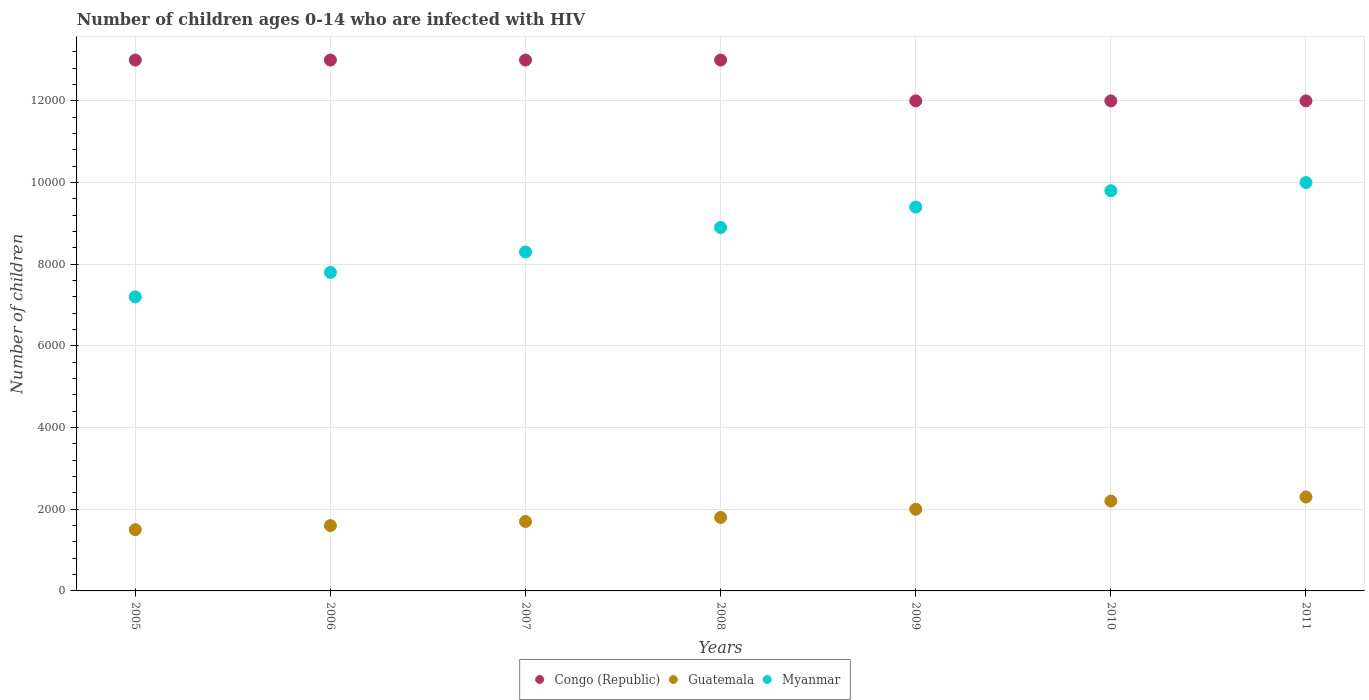How many different coloured dotlines are there?
Make the answer very short. 3. Is the number of dotlines equal to the number of legend labels?
Make the answer very short. Yes. What is the number of HIV infected children in Congo (Republic) in 2005?
Ensure brevity in your answer.  1.30e+04. Across all years, what is the maximum number of HIV infected children in Congo (Republic)?
Keep it short and to the point. 1.30e+04. Across all years, what is the minimum number of HIV infected children in Congo (Republic)?
Your answer should be compact. 1.20e+04. In which year was the number of HIV infected children in Congo (Republic) maximum?
Your response must be concise. 2005. In which year was the number of HIV infected children in Congo (Republic) minimum?
Keep it short and to the point. 2009. What is the total number of HIV infected children in Guatemala in the graph?
Provide a short and direct response. 1.31e+04. What is the difference between the number of HIV infected children in Guatemala in 2008 and that in 2011?
Offer a very short reply. -500. What is the difference between the number of HIV infected children in Guatemala in 2006 and the number of HIV infected children in Myanmar in 2005?
Make the answer very short. -5600. What is the average number of HIV infected children in Guatemala per year?
Make the answer very short. 1871.43. In the year 2010, what is the difference between the number of HIV infected children in Congo (Republic) and number of HIV infected children in Myanmar?
Offer a terse response. 2200. What is the ratio of the number of HIV infected children in Guatemala in 2007 to that in 2010?
Make the answer very short. 0.77. Is the number of HIV infected children in Myanmar in 2005 less than that in 2007?
Provide a succinct answer. Yes. Is the difference between the number of HIV infected children in Congo (Republic) in 2005 and 2006 greater than the difference between the number of HIV infected children in Myanmar in 2005 and 2006?
Provide a short and direct response. Yes. What is the difference between the highest and the lowest number of HIV infected children in Congo (Republic)?
Ensure brevity in your answer.  1000. In how many years, is the number of HIV infected children in Congo (Republic) greater than the average number of HIV infected children in Congo (Republic) taken over all years?
Your answer should be very brief. 4. Is the sum of the number of HIV infected children in Guatemala in 2005 and 2007 greater than the maximum number of HIV infected children in Congo (Republic) across all years?
Offer a very short reply. No. Is it the case that in every year, the sum of the number of HIV infected children in Myanmar and number of HIV infected children in Guatemala  is greater than the number of HIV infected children in Congo (Republic)?
Offer a terse response. No. Does the number of HIV infected children in Congo (Republic) monotonically increase over the years?
Make the answer very short. No. How many years are there in the graph?
Give a very brief answer. 7. Are the values on the major ticks of Y-axis written in scientific E-notation?
Your response must be concise. No. Does the graph contain grids?
Keep it short and to the point. Yes. How many legend labels are there?
Your answer should be very brief. 3. How are the legend labels stacked?
Keep it short and to the point. Horizontal. What is the title of the graph?
Keep it short and to the point. Number of children ages 0-14 who are infected with HIV. What is the label or title of the X-axis?
Provide a short and direct response. Years. What is the label or title of the Y-axis?
Your response must be concise. Number of children. What is the Number of children of Congo (Republic) in 2005?
Provide a short and direct response. 1.30e+04. What is the Number of children of Guatemala in 2005?
Provide a short and direct response. 1500. What is the Number of children of Myanmar in 2005?
Give a very brief answer. 7200. What is the Number of children in Congo (Republic) in 2006?
Your answer should be compact. 1.30e+04. What is the Number of children of Guatemala in 2006?
Your response must be concise. 1600. What is the Number of children in Myanmar in 2006?
Provide a short and direct response. 7800. What is the Number of children of Congo (Republic) in 2007?
Provide a short and direct response. 1.30e+04. What is the Number of children of Guatemala in 2007?
Give a very brief answer. 1700. What is the Number of children in Myanmar in 2007?
Keep it short and to the point. 8300. What is the Number of children in Congo (Republic) in 2008?
Your answer should be very brief. 1.30e+04. What is the Number of children of Guatemala in 2008?
Your answer should be compact. 1800. What is the Number of children of Myanmar in 2008?
Offer a terse response. 8900. What is the Number of children in Congo (Republic) in 2009?
Offer a terse response. 1.20e+04. What is the Number of children of Myanmar in 2009?
Offer a very short reply. 9400. What is the Number of children of Congo (Republic) in 2010?
Keep it short and to the point. 1.20e+04. What is the Number of children in Guatemala in 2010?
Give a very brief answer. 2200. What is the Number of children of Myanmar in 2010?
Offer a very short reply. 9800. What is the Number of children in Congo (Republic) in 2011?
Keep it short and to the point. 1.20e+04. What is the Number of children in Guatemala in 2011?
Keep it short and to the point. 2300. Across all years, what is the maximum Number of children in Congo (Republic)?
Make the answer very short. 1.30e+04. Across all years, what is the maximum Number of children in Guatemala?
Provide a succinct answer. 2300. Across all years, what is the maximum Number of children of Myanmar?
Offer a terse response. 10000. Across all years, what is the minimum Number of children in Congo (Republic)?
Offer a very short reply. 1.20e+04. Across all years, what is the minimum Number of children of Guatemala?
Make the answer very short. 1500. Across all years, what is the minimum Number of children of Myanmar?
Offer a terse response. 7200. What is the total Number of children in Congo (Republic) in the graph?
Offer a terse response. 8.80e+04. What is the total Number of children in Guatemala in the graph?
Your answer should be compact. 1.31e+04. What is the total Number of children of Myanmar in the graph?
Your response must be concise. 6.14e+04. What is the difference between the Number of children in Congo (Republic) in 2005 and that in 2006?
Your answer should be very brief. 0. What is the difference between the Number of children of Guatemala in 2005 and that in 2006?
Offer a very short reply. -100. What is the difference between the Number of children of Myanmar in 2005 and that in 2006?
Keep it short and to the point. -600. What is the difference between the Number of children of Congo (Republic) in 2005 and that in 2007?
Your answer should be very brief. 0. What is the difference between the Number of children of Guatemala in 2005 and that in 2007?
Make the answer very short. -200. What is the difference between the Number of children of Myanmar in 2005 and that in 2007?
Offer a very short reply. -1100. What is the difference between the Number of children of Guatemala in 2005 and that in 2008?
Your answer should be very brief. -300. What is the difference between the Number of children of Myanmar in 2005 and that in 2008?
Offer a very short reply. -1700. What is the difference between the Number of children in Congo (Republic) in 2005 and that in 2009?
Ensure brevity in your answer.  1000. What is the difference between the Number of children in Guatemala in 2005 and that in 2009?
Make the answer very short. -500. What is the difference between the Number of children in Myanmar in 2005 and that in 2009?
Make the answer very short. -2200. What is the difference between the Number of children of Guatemala in 2005 and that in 2010?
Give a very brief answer. -700. What is the difference between the Number of children in Myanmar in 2005 and that in 2010?
Keep it short and to the point. -2600. What is the difference between the Number of children of Congo (Republic) in 2005 and that in 2011?
Provide a succinct answer. 1000. What is the difference between the Number of children in Guatemala in 2005 and that in 2011?
Make the answer very short. -800. What is the difference between the Number of children of Myanmar in 2005 and that in 2011?
Provide a succinct answer. -2800. What is the difference between the Number of children of Congo (Republic) in 2006 and that in 2007?
Offer a very short reply. 0. What is the difference between the Number of children in Guatemala in 2006 and that in 2007?
Provide a short and direct response. -100. What is the difference between the Number of children of Myanmar in 2006 and that in 2007?
Offer a terse response. -500. What is the difference between the Number of children in Congo (Republic) in 2006 and that in 2008?
Offer a very short reply. 0. What is the difference between the Number of children in Guatemala in 2006 and that in 2008?
Give a very brief answer. -200. What is the difference between the Number of children in Myanmar in 2006 and that in 2008?
Make the answer very short. -1100. What is the difference between the Number of children in Congo (Republic) in 2006 and that in 2009?
Provide a succinct answer. 1000. What is the difference between the Number of children of Guatemala in 2006 and that in 2009?
Give a very brief answer. -400. What is the difference between the Number of children in Myanmar in 2006 and that in 2009?
Your response must be concise. -1600. What is the difference between the Number of children of Guatemala in 2006 and that in 2010?
Make the answer very short. -600. What is the difference between the Number of children in Myanmar in 2006 and that in 2010?
Your response must be concise. -2000. What is the difference between the Number of children of Congo (Republic) in 2006 and that in 2011?
Your answer should be very brief. 1000. What is the difference between the Number of children of Guatemala in 2006 and that in 2011?
Your response must be concise. -700. What is the difference between the Number of children in Myanmar in 2006 and that in 2011?
Provide a short and direct response. -2200. What is the difference between the Number of children in Guatemala in 2007 and that in 2008?
Give a very brief answer. -100. What is the difference between the Number of children of Myanmar in 2007 and that in 2008?
Offer a very short reply. -600. What is the difference between the Number of children in Congo (Republic) in 2007 and that in 2009?
Give a very brief answer. 1000. What is the difference between the Number of children in Guatemala in 2007 and that in 2009?
Your answer should be very brief. -300. What is the difference between the Number of children of Myanmar in 2007 and that in 2009?
Make the answer very short. -1100. What is the difference between the Number of children of Guatemala in 2007 and that in 2010?
Make the answer very short. -500. What is the difference between the Number of children of Myanmar in 2007 and that in 2010?
Provide a short and direct response. -1500. What is the difference between the Number of children in Guatemala in 2007 and that in 2011?
Keep it short and to the point. -600. What is the difference between the Number of children of Myanmar in 2007 and that in 2011?
Give a very brief answer. -1700. What is the difference between the Number of children of Congo (Republic) in 2008 and that in 2009?
Your answer should be compact. 1000. What is the difference between the Number of children in Guatemala in 2008 and that in 2009?
Provide a succinct answer. -200. What is the difference between the Number of children of Myanmar in 2008 and that in 2009?
Provide a short and direct response. -500. What is the difference between the Number of children in Congo (Republic) in 2008 and that in 2010?
Make the answer very short. 1000. What is the difference between the Number of children in Guatemala in 2008 and that in 2010?
Your response must be concise. -400. What is the difference between the Number of children of Myanmar in 2008 and that in 2010?
Provide a succinct answer. -900. What is the difference between the Number of children of Guatemala in 2008 and that in 2011?
Offer a very short reply. -500. What is the difference between the Number of children in Myanmar in 2008 and that in 2011?
Your answer should be compact. -1100. What is the difference between the Number of children in Congo (Republic) in 2009 and that in 2010?
Your answer should be compact. 0. What is the difference between the Number of children in Guatemala in 2009 and that in 2010?
Keep it short and to the point. -200. What is the difference between the Number of children of Myanmar in 2009 and that in 2010?
Ensure brevity in your answer.  -400. What is the difference between the Number of children in Guatemala in 2009 and that in 2011?
Keep it short and to the point. -300. What is the difference between the Number of children in Myanmar in 2009 and that in 2011?
Provide a succinct answer. -600. What is the difference between the Number of children of Congo (Republic) in 2010 and that in 2011?
Keep it short and to the point. 0. What is the difference between the Number of children of Guatemala in 2010 and that in 2011?
Keep it short and to the point. -100. What is the difference between the Number of children in Myanmar in 2010 and that in 2011?
Offer a terse response. -200. What is the difference between the Number of children of Congo (Republic) in 2005 and the Number of children of Guatemala in 2006?
Make the answer very short. 1.14e+04. What is the difference between the Number of children in Congo (Republic) in 2005 and the Number of children in Myanmar in 2006?
Give a very brief answer. 5200. What is the difference between the Number of children of Guatemala in 2005 and the Number of children of Myanmar in 2006?
Provide a succinct answer. -6300. What is the difference between the Number of children in Congo (Republic) in 2005 and the Number of children in Guatemala in 2007?
Provide a succinct answer. 1.13e+04. What is the difference between the Number of children in Congo (Republic) in 2005 and the Number of children in Myanmar in 2007?
Keep it short and to the point. 4700. What is the difference between the Number of children of Guatemala in 2005 and the Number of children of Myanmar in 2007?
Your answer should be very brief. -6800. What is the difference between the Number of children of Congo (Republic) in 2005 and the Number of children of Guatemala in 2008?
Provide a succinct answer. 1.12e+04. What is the difference between the Number of children of Congo (Republic) in 2005 and the Number of children of Myanmar in 2008?
Give a very brief answer. 4100. What is the difference between the Number of children in Guatemala in 2005 and the Number of children in Myanmar in 2008?
Provide a succinct answer. -7400. What is the difference between the Number of children of Congo (Republic) in 2005 and the Number of children of Guatemala in 2009?
Offer a terse response. 1.10e+04. What is the difference between the Number of children of Congo (Republic) in 2005 and the Number of children of Myanmar in 2009?
Offer a terse response. 3600. What is the difference between the Number of children in Guatemala in 2005 and the Number of children in Myanmar in 2009?
Provide a short and direct response. -7900. What is the difference between the Number of children of Congo (Republic) in 2005 and the Number of children of Guatemala in 2010?
Your answer should be compact. 1.08e+04. What is the difference between the Number of children in Congo (Republic) in 2005 and the Number of children in Myanmar in 2010?
Offer a very short reply. 3200. What is the difference between the Number of children in Guatemala in 2005 and the Number of children in Myanmar in 2010?
Offer a terse response. -8300. What is the difference between the Number of children of Congo (Republic) in 2005 and the Number of children of Guatemala in 2011?
Your response must be concise. 1.07e+04. What is the difference between the Number of children of Congo (Republic) in 2005 and the Number of children of Myanmar in 2011?
Your response must be concise. 3000. What is the difference between the Number of children of Guatemala in 2005 and the Number of children of Myanmar in 2011?
Offer a terse response. -8500. What is the difference between the Number of children in Congo (Republic) in 2006 and the Number of children in Guatemala in 2007?
Ensure brevity in your answer.  1.13e+04. What is the difference between the Number of children of Congo (Republic) in 2006 and the Number of children of Myanmar in 2007?
Offer a very short reply. 4700. What is the difference between the Number of children of Guatemala in 2006 and the Number of children of Myanmar in 2007?
Provide a short and direct response. -6700. What is the difference between the Number of children of Congo (Republic) in 2006 and the Number of children of Guatemala in 2008?
Offer a terse response. 1.12e+04. What is the difference between the Number of children of Congo (Republic) in 2006 and the Number of children of Myanmar in 2008?
Offer a terse response. 4100. What is the difference between the Number of children of Guatemala in 2006 and the Number of children of Myanmar in 2008?
Give a very brief answer. -7300. What is the difference between the Number of children of Congo (Republic) in 2006 and the Number of children of Guatemala in 2009?
Offer a very short reply. 1.10e+04. What is the difference between the Number of children in Congo (Republic) in 2006 and the Number of children in Myanmar in 2009?
Your response must be concise. 3600. What is the difference between the Number of children in Guatemala in 2006 and the Number of children in Myanmar in 2009?
Provide a short and direct response. -7800. What is the difference between the Number of children in Congo (Republic) in 2006 and the Number of children in Guatemala in 2010?
Provide a short and direct response. 1.08e+04. What is the difference between the Number of children of Congo (Republic) in 2006 and the Number of children of Myanmar in 2010?
Give a very brief answer. 3200. What is the difference between the Number of children of Guatemala in 2006 and the Number of children of Myanmar in 2010?
Give a very brief answer. -8200. What is the difference between the Number of children of Congo (Republic) in 2006 and the Number of children of Guatemala in 2011?
Offer a terse response. 1.07e+04. What is the difference between the Number of children of Congo (Republic) in 2006 and the Number of children of Myanmar in 2011?
Ensure brevity in your answer.  3000. What is the difference between the Number of children in Guatemala in 2006 and the Number of children in Myanmar in 2011?
Ensure brevity in your answer.  -8400. What is the difference between the Number of children in Congo (Republic) in 2007 and the Number of children in Guatemala in 2008?
Keep it short and to the point. 1.12e+04. What is the difference between the Number of children of Congo (Republic) in 2007 and the Number of children of Myanmar in 2008?
Offer a terse response. 4100. What is the difference between the Number of children in Guatemala in 2007 and the Number of children in Myanmar in 2008?
Ensure brevity in your answer.  -7200. What is the difference between the Number of children of Congo (Republic) in 2007 and the Number of children of Guatemala in 2009?
Your answer should be very brief. 1.10e+04. What is the difference between the Number of children in Congo (Republic) in 2007 and the Number of children in Myanmar in 2009?
Give a very brief answer. 3600. What is the difference between the Number of children of Guatemala in 2007 and the Number of children of Myanmar in 2009?
Give a very brief answer. -7700. What is the difference between the Number of children in Congo (Republic) in 2007 and the Number of children in Guatemala in 2010?
Offer a very short reply. 1.08e+04. What is the difference between the Number of children in Congo (Republic) in 2007 and the Number of children in Myanmar in 2010?
Ensure brevity in your answer.  3200. What is the difference between the Number of children in Guatemala in 2007 and the Number of children in Myanmar in 2010?
Your response must be concise. -8100. What is the difference between the Number of children in Congo (Republic) in 2007 and the Number of children in Guatemala in 2011?
Offer a very short reply. 1.07e+04. What is the difference between the Number of children of Congo (Republic) in 2007 and the Number of children of Myanmar in 2011?
Keep it short and to the point. 3000. What is the difference between the Number of children of Guatemala in 2007 and the Number of children of Myanmar in 2011?
Offer a very short reply. -8300. What is the difference between the Number of children of Congo (Republic) in 2008 and the Number of children of Guatemala in 2009?
Provide a short and direct response. 1.10e+04. What is the difference between the Number of children of Congo (Republic) in 2008 and the Number of children of Myanmar in 2009?
Provide a succinct answer. 3600. What is the difference between the Number of children in Guatemala in 2008 and the Number of children in Myanmar in 2009?
Ensure brevity in your answer.  -7600. What is the difference between the Number of children in Congo (Republic) in 2008 and the Number of children in Guatemala in 2010?
Offer a very short reply. 1.08e+04. What is the difference between the Number of children of Congo (Republic) in 2008 and the Number of children of Myanmar in 2010?
Your answer should be compact. 3200. What is the difference between the Number of children of Guatemala in 2008 and the Number of children of Myanmar in 2010?
Give a very brief answer. -8000. What is the difference between the Number of children in Congo (Republic) in 2008 and the Number of children in Guatemala in 2011?
Provide a short and direct response. 1.07e+04. What is the difference between the Number of children of Congo (Republic) in 2008 and the Number of children of Myanmar in 2011?
Offer a terse response. 3000. What is the difference between the Number of children of Guatemala in 2008 and the Number of children of Myanmar in 2011?
Provide a succinct answer. -8200. What is the difference between the Number of children of Congo (Republic) in 2009 and the Number of children of Guatemala in 2010?
Provide a short and direct response. 9800. What is the difference between the Number of children in Congo (Republic) in 2009 and the Number of children in Myanmar in 2010?
Make the answer very short. 2200. What is the difference between the Number of children in Guatemala in 2009 and the Number of children in Myanmar in 2010?
Your answer should be very brief. -7800. What is the difference between the Number of children of Congo (Republic) in 2009 and the Number of children of Guatemala in 2011?
Provide a short and direct response. 9700. What is the difference between the Number of children in Guatemala in 2009 and the Number of children in Myanmar in 2011?
Provide a short and direct response. -8000. What is the difference between the Number of children of Congo (Republic) in 2010 and the Number of children of Guatemala in 2011?
Keep it short and to the point. 9700. What is the difference between the Number of children in Guatemala in 2010 and the Number of children in Myanmar in 2011?
Keep it short and to the point. -7800. What is the average Number of children of Congo (Republic) per year?
Make the answer very short. 1.26e+04. What is the average Number of children in Guatemala per year?
Your answer should be compact. 1871.43. What is the average Number of children in Myanmar per year?
Make the answer very short. 8771.43. In the year 2005, what is the difference between the Number of children of Congo (Republic) and Number of children of Guatemala?
Make the answer very short. 1.15e+04. In the year 2005, what is the difference between the Number of children of Congo (Republic) and Number of children of Myanmar?
Keep it short and to the point. 5800. In the year 2005, what is the difference between the Number of children in Guatemala and Number of children in Myanmar?
Make the answer very short. -5700. In the year 2006, what is the difference between the Number of children in Congo (Republic) and Number of children in Guatemala?
Offer a terse response. 1.14e+04. In the year 2006, what is the difference between the Number of children in Congo (Republic) and Number of children in Myanmar?
Offer a terse response. 5200. In the year 2006, what is the difference between the Number of children of Guatemala and Number of children of Myanmar?
Your response must be concise. -6200. In the year 2007, what is the difference between the Number of children in Congo (Republic) and Number of children in Guatemala?
Your answer should be compact. 1.13e+04. In the year 2007, what is the difference between the Number of children of Congo (Republic) and Number of children of Myanmar?
Your answer should be very brief. 4700. In the year 2007, what is the difference between the Number of children in Guatemala and Number of children in Myanmar?
Your response must be concise. -6600. In the year 2008, what is the difference between the Number of children of Congo (Republic) and Number of children of Guatemala?
Your answer should be compact. 1.12e+04. In the year 2008, what is the difference between the Number of children in Congo (Republic) and Number of children in Myanmar?
Your answer should be compact. 4100. In the year 2008, what is the difference between the Number of children of Guatemala and Number of children of Myanmar?
Keep it short and to the point. -7100. In the year 2009, what is the difference between the Number of children in Congo (Republic) and Number of children in Guatemala?
Offer a very short reply. 10000. In the year 2009, what is the difference between the Number of children of Congo (Republic) and Number of children of Myanmar?
Provide a succinct answer. 2600. In the year 2009, what is the difference between the Number of children in Guatemala and Number of children in Myanmar?
Offer a terse response. -7400. In the year 2010, what is the difference between the Number of children of Congo (Republic) and Number of children of Guatemala?
Provide a succinct answer. 9800. In the year 2010, what is the difference between the Number of children in Congo (Republic) and Number of children in Myanmar?
Your answer should be compact. 2200. In the year 2010, what is the difference between the Number of children in Guatemala and Number of children in Myanmar?
Keep it short and to the point. -7600. In the year 2011, what is the difference between the Number of children in Congo (Republic) and Number of children in Guatemala?
Your answer should be very brief. 9700. In the year 2011, what is the difference between the Number of children in Guatemala and Number of children in Myanmar?
Give a very brief answer. -7700. What is the ratio of the Number of children of Congo (Republic) in 2005 to that in 2006?
Give a very brief answer. 1. What is the ratio of the Number of children in Myanmar in 2005 to that in 2006?
Your response must be concise. 0.92. What is the ratio of the Number of children of Guatemala in 2005 to that in 2007?
Offer a terse response. 0.88. What is the ratio of the Number of children in Myanmar in 2005 to that in 2007?
Give a very brief answer. 0.87. What is the ratio of the Number of children in Guatemala in 2005 to that in 2008?
Provide a short and direct response. 0.83. What is the ratio of the Number of children in Myanmar in 2005 to that in 2008?
Your answer should be compact. 0.81. What is the ratio of the Number of children in Congo (Republic) in 2005 to that in 2009?
Offer a terse response. 1.08. What is the ratio of the Number of children in Guatemala in 2005 to that in 2009?
Offer a very short reply. 0.75. What is the ratio of the Number of children in Myanmar in 2005 to that in 2009?
Your answer should be compact. 0.77. What is the ratio of the Number of children in Guatemala in 2005 to that in 2010?
Give a very brief answer. 0.68. What is the ratio of the Number of children of Myanmar in 2005 to that in 2010?
Provide a short and direct response. 0.73. What is the ratio of the Number of children in Guatemala in 2005 to that in 2011?
Your answer should be very brief. 0.65. What is the ratio of the Number of children in Myanmar in 2005 to that in 2011?
Your response must be concise. 0.72. What is the ratio of the Number of children of Guatemala in 2006 to that in 2007?
Give a very brief answer. 0.94. What is the ratio of the Number of children of Myanmar in 2006 to that in 2007?
Ensure brevity in your answer.  0.94. What is the ratio of the Number of children of Myanmar in 2006 to that in 2008?
Provide a short and direct response. 0.88. What is the ratio of the Number of children in Congo (Republic) in 2006 to that in 2009?
Keep it short and to the point. 1.08. What is the ratio of the Number of children of Myanmar in 2006 to that in 2009?
Offer a terse response. 0.83. What is the ratio of the Number of children in Congo (Republic) in 2006 to that in 2010?
Make the answer very short. 1.08. What is the ratio of the Number of children in Guatemala in 2006 to that in 2010?
Your response must be concise. 0.73. What is the ratio of the Number of children of Myanmar in 2006 to that in 2010?
Offer a terse response. 0.8. What is the ratio of the Number of children in Congo (Republic) in 2006 to that in 2011?
Your response must be concise. 1.08. What is the ratio of the Number of children in Guatemala in 2006 to that in 2011?
Provide a succinct answer. 0.7. What is the ratio of the Number of children of Myanmar in 2006 to that in 2011?
Your response must be concise. 0.78. What is the ratio of the Number of children in Congo (Republic) in 2007 to that in 2008?
Provide a succinct answer. 1. What is the ratio of the Number of children of Guatemala in 2007 to that in 2008?
Keep it short and to the point. 0.94. What is the ratio of the Number of children in Myanmar in 2007 to that in 2008?
Provide a succinct answer. 0.93. What is the ratio of the Number of children of Guatemala in 2007 to that in 2009?
Ensure brevity in your answer.  0.85. What is the ratio of the Number of children of Myanmar in 2007 to that in 2009?
Your answer should be very brief. 0.88. What is the ratio of the Number of children in Guatemala in 2007 to that in 2010?
Your answer should be compact. 0.77. What is the ratio of the Number of children in Myanmar in 2007 to that in 2010?
Provide a succinct answer. 0.85. What is the ratio of the Number of children of Congo (Republic) in 2007 to that in 2011?
Your answer should be compact. 1.08. What is the ratio of the Number of children of Guatemala in 2007 to that in 2011?
Ensure brevity in your answer.  0.74. What is the ratio of the Number of children in Myanmar in 2007 to that in 2011?
Your answer should be compact. 0.83. What is the ratio of the Number of children of Congo (Republic) in 2008 to that in 2009?
Make the answer very short. 1.08. What is the ratio of the Number of children in Myanmar in 2008 to that in 2009?
Make the answer very short. 0.95. What is the ratio of the Number of children of Congo (Republic) in 2008 to that in 2010?
Your response must be concise. 1.08. What is the ratio of the Number of children of Guatemala in 2008 to that in 2010?
Give a very brief answer. 0.82. What is the ratio of the Number of children in Myanmar in 2008 to that in 2010?
Your answer should be compact. 0.91. What is the ratio of the Number of children of Guatemala in 2008 to that in 2011?
Your answer should be compact. 0.78. What is the ratio of the Number of children in Myanmar in 2008 to that in 2011?
Give a very brief answer. 0.89. What is the ratio of the Number of children of Myanmar in 2009 to that in 2010?
Your answer should be compact. 0.96. What is the ratio of the Number of children in Congo (Republic) in 2009 to that in 2011?
Your answer should be compact. 1. What is the ratio of the Number of children of Guatemala in 2009 to that in 2011?
Provide a succinct answer. 0.87. What is the ratio of the Number of children in Myanmar in 2009 to that in 2011?
Your answer should be very brief. 0.94. What is the ratio of the Number of children in Congo (Republic) in 2010 to that in 2011?
Offer a terse response. 1. What is the ratio of the Number of children of Guatemala in 2010 to that in 2011?
Your response must be concise. 0.96. What is the ratio of the Number of children in Myanmar in 2010 to that in 2011?
Offer a terse response. 0.98. What is the difference between the highest and the second highest Number of children of Guatemala?
Make the answer very short. 100. What is the difference between the highest and the second highest Number of children in Myanmar?
Provide a short and direct response. 200. What is the difference between the highest and the lowest Number of children in Guatemala?
Your answer should be very brief. 800. What is the difference between the highest and the lowest Number of children of Myanmar?
Your answer should be very brief. 2800. 